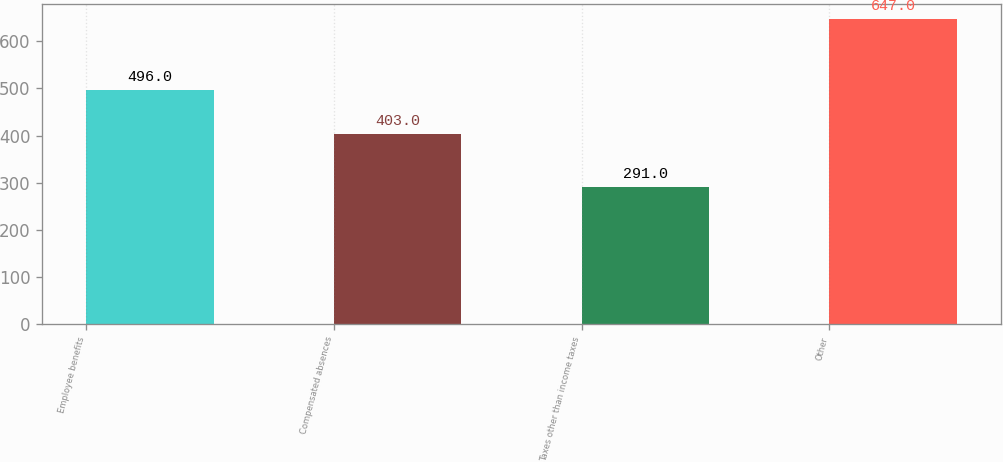<chart> <loc_0><loc_0><loc_500><loc_500><bar_chart><fcel>Employee benefits<fcel>Compensated absences<fcel>Taxes other than income taxes<fcel>Other<nl><fcel>496<fcel>403<fcel>291<fcel>647<nl></chart> 